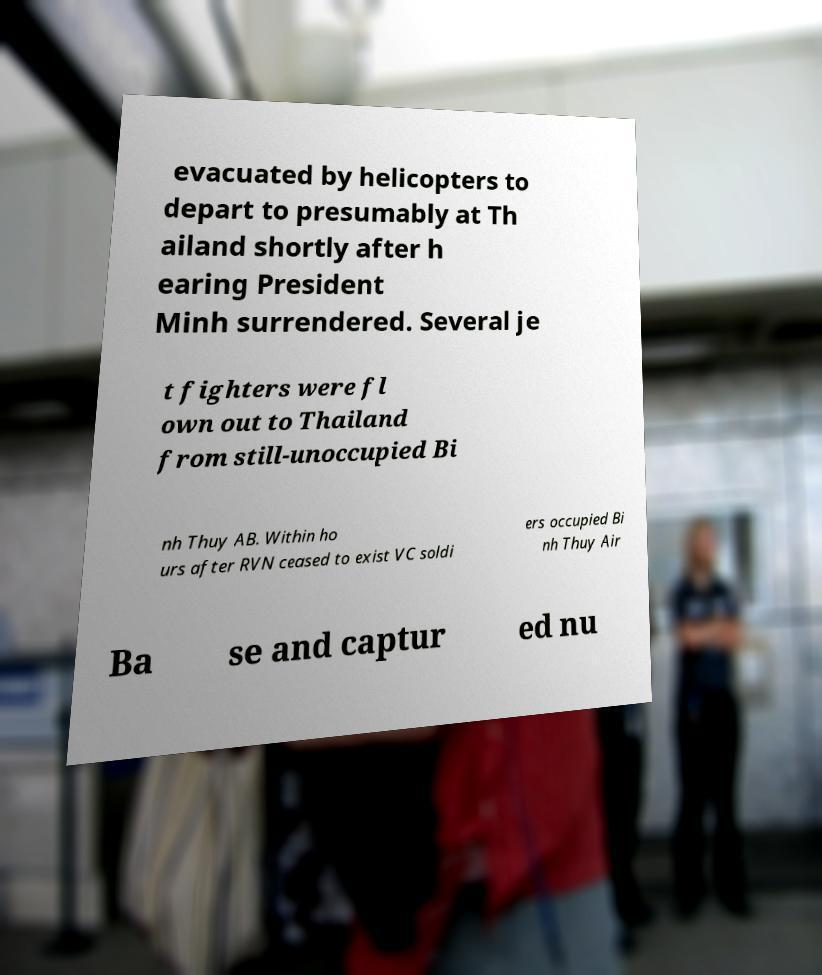Could you assist in decoding the text presented in this image and type it out clearly? evacuated by helicopters to depart to presumably at Th ailand shortly after h earing President Minh surrendered. Several je t fighters were fl own out to Thailand from still-unoccupied Bi nh Thuy AB. Within ho urs after RVN ceased to exist VC soldi ers occupied Bi nh Thuy Air Ba se and captur ed nu 